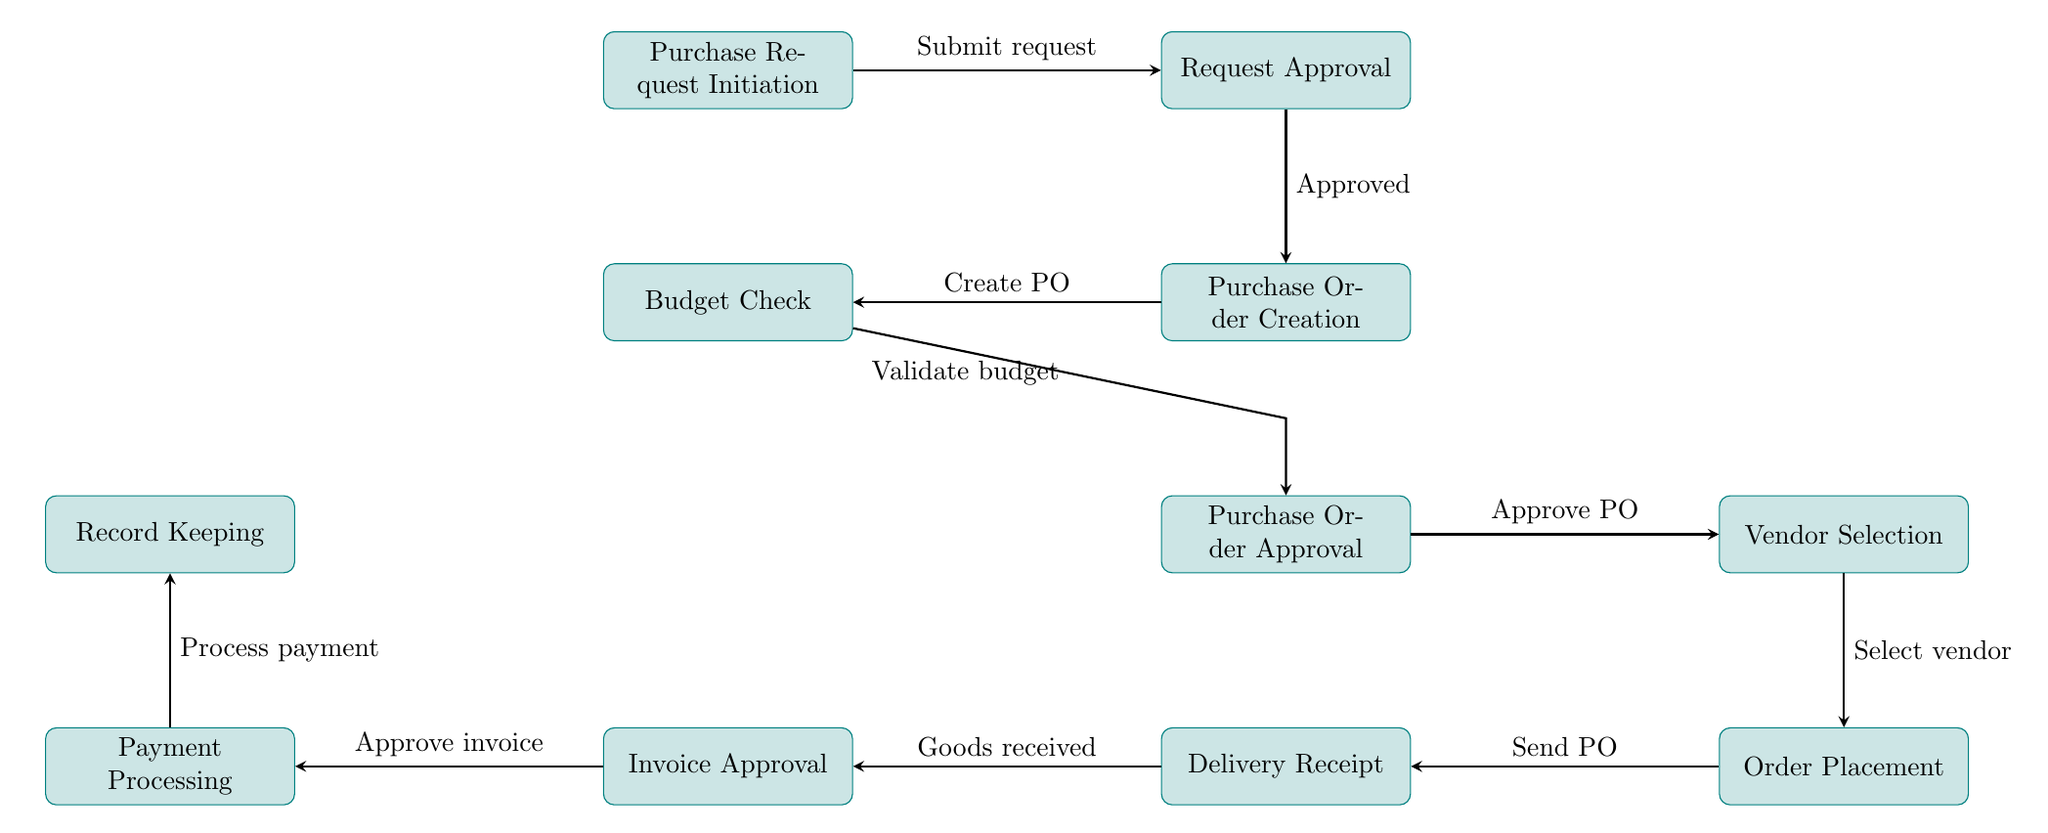What is the first step in the purchase order workflow? The first step in the diagram is indicated by the node at the top, which is "Purchase Request Initiation." This begins the workflow with the initiation of a purchase request.
Answer: Purchase Request Initiation How many total nodes are in the diagram? To find the total number of nodes, we count each labeled process in the diagram. There are ten distinct processes represented in the flowchart.
Answer: 10 What is the relationship between "Request Approval" and "Purchase Order Creation"? The diagram shows an arrow from "Request Approval" to "Purchase Order Creation," indicating that the purchase order creation process occurs after the request has been approved.
Answer: Approved What happens after "Vendor Selection"? According to the flowchart, after "Vendor Selection," the next step is "Order Placement." The arrow connecting these two nodes illustrates this sequential relationship.
Answer: Order Placement Which node is responsible for validating the budget? The node that indicates the budget validation task is labeled "Budget Check." It is adjacent to "Purchase Order Creation," indicating it checks the budget at that stage of the process.
Answer: Budget Check What is the last step in the purchase order workflow? The last step in the workflow is found at the bottom of the diagram, which is "Record Keeping." This node represents the finalization of the process once payment has been processed.
Answer: Record Keeping How are "Delivery Receipt" and "Invoice Approval" connected? The diagram shows a direct arrow from "Delivery Receipt" to "Invoice Approval," indicating that invoice approval follows after the delivery receipt has been acknowledged. This illustrates the dependency of invoice approval on the delivery process.
Answer: Goods received Which process directly precedes "Payment Processing"? Right before "Payment Processing," the diagram indicates "Invoice Approval." The arrow from "Invoice Approval" to "Payment Processing" shows that payment processing occurs after the invoice has been approved.
Answer: Invoice Approval What combination of steps comes after budget validation? Once budget validation is completed, the workflow moves to "Purchase Order Approval," which then proceeds to "Vendor Selection." This requires understanding that validation leads to approval and selection.
Answer: Purchase Order Approval 